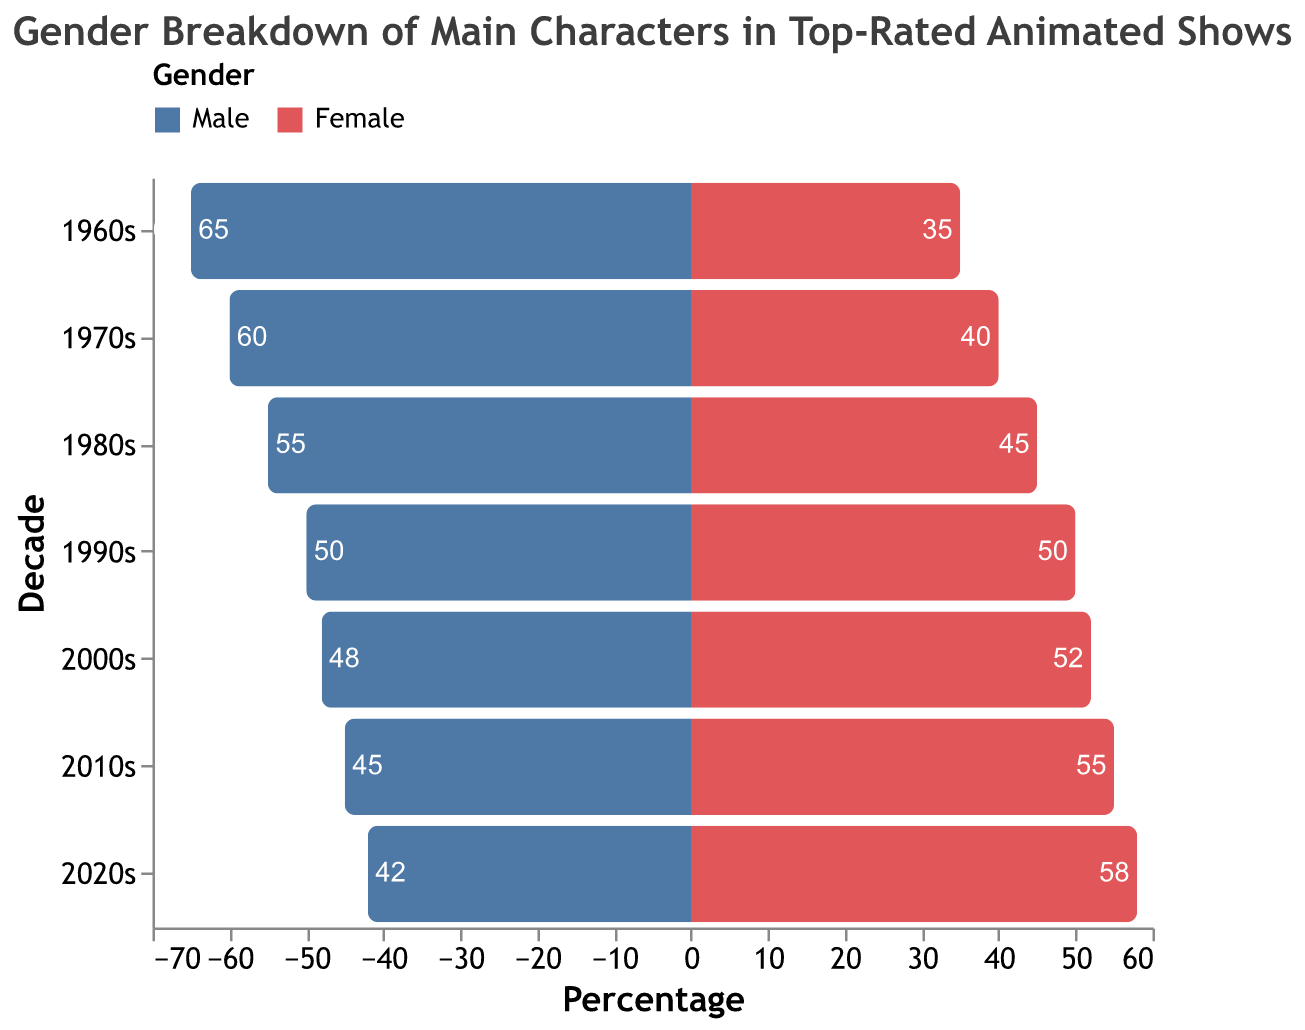What is the title of the figure? The title is displayed at the top of the figure. It reads, "Gender Breakdown of Main Characters in Top-Rated Animated Shows".
Answer: Gender Breakdown of Main Characters in Top-Rated Animated Shows Which decade has the highest percentage of female main characters? By comparing the bars for females across the decades, the 2020s decade has the highest percentage of female main characters at 58%.
Answer: 2020s How did the percentage of male main characters change from the 1960s to the 2020s? The percentage of male main characters in the 1960s is 65%. In the 2020s, it is 42%. The change is calculated as 42 - 65, which results in a decrease of 23 percentage points.
Answer: Decreased by 23 percentage points Which decade shows an equal percentage of male and female main characters? Looking at the data, the 1990s shows a 50% male and 50% female split, making it the only decade with equal percentages for both genders.
Answer: 1990s For the 2000s, how much greater is the percentage of female main characters compared to the percentage of male main characters? In the 2000s, the percentage of female main characters is 52%, and the percentage of male main characters is 48%. The difference is calculated as 52% - 48%, resulting in 4%.
Answer: 4% In which decade did female main characters first surpass male main characters in percentage terms? By observing the percentages for each decade, the first time female main characters surpass male main characters is in the 2000s: 52% female vs. 48% male.
Answer: 2000s Calculate the average percentage of female main characters from the 1960s to the 2020s. Summing the percentages of female main characters for each decade (35 + 40 + 45 + 50 + 52 + 55 + 58) results in 335. Dividing by the number of decades, 335 / 7, gives an average of approximately 47.9%.
Answer: Approximately 47.9% What is the general trend in the percentage of male main characters from the 1960s to the 2020s? Observing the data for male main characters shows a consistent decrease in percentage, starting at 65% in the 1960s and gradually decreasing to 42% in the 2020s.
Answer: Decreasing trend Compare the percentage of female main characters in the 1980s and the 2010s. In the 1980s, the percentage of female main characters is 45%. In the 2010s, it is 55%. Comparing these, the percentage increased by 10 percentage points from the 1980s to the 2010s.
Answer: Increased by 10 percentage points 